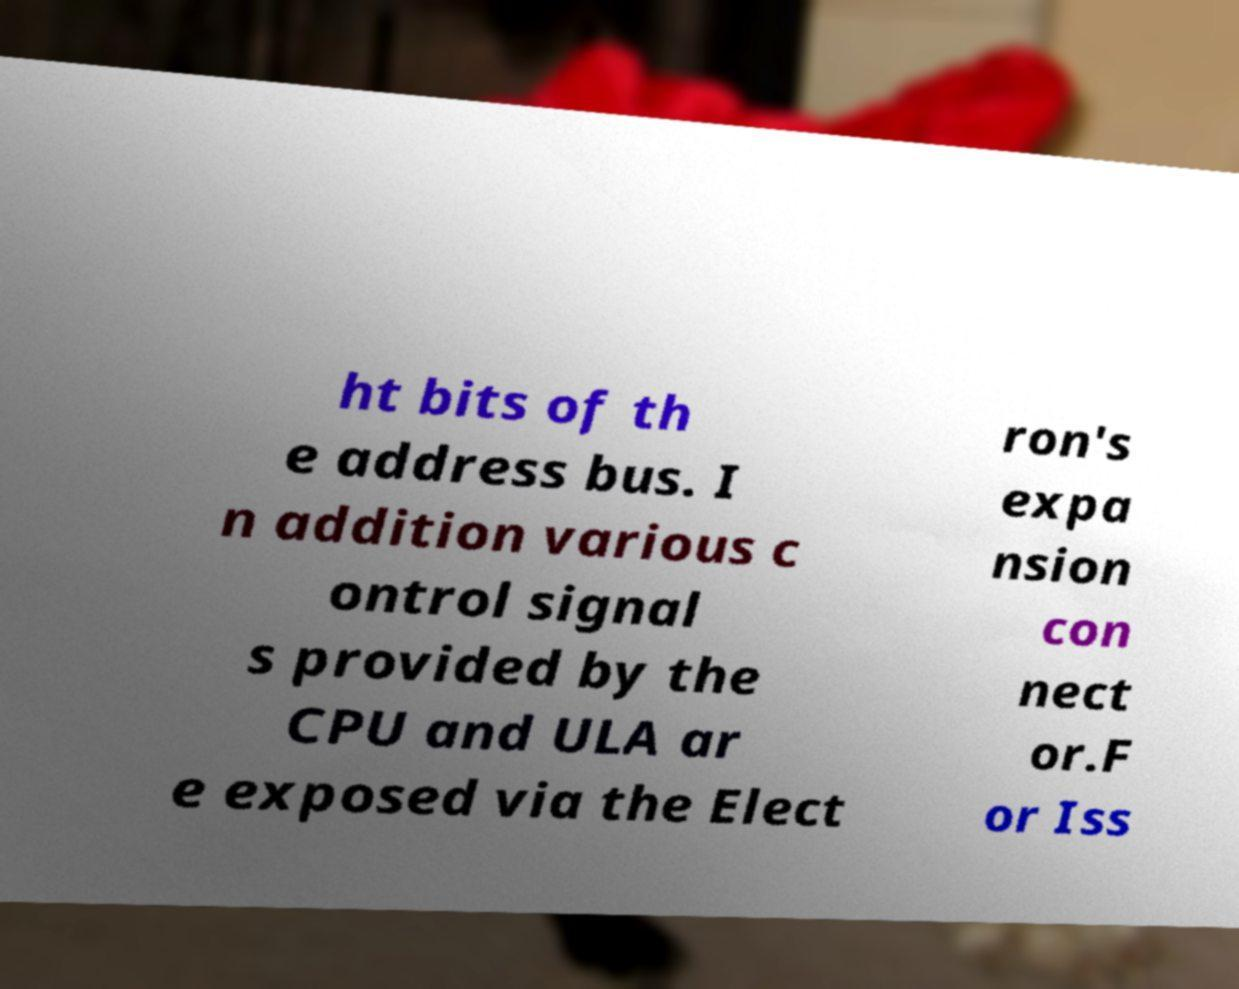What messages or text are displayed in this image? I need them in a readable, typed format. ht bits of th e address bus. I n addition various c ontrol signal s provided by the CPU and ULA ar e exposed via the Elect ron's expa nsion con nect or.F or Iss 